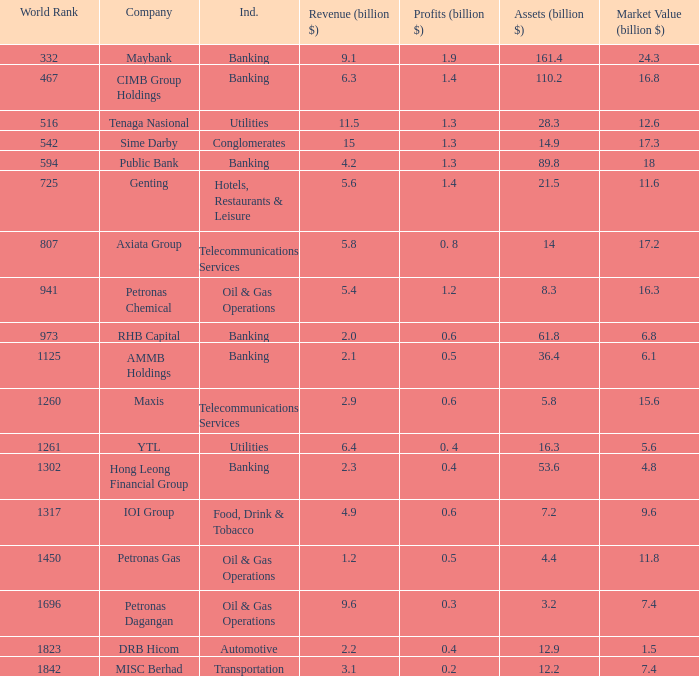Name the market value for rhb capital 6.8. 